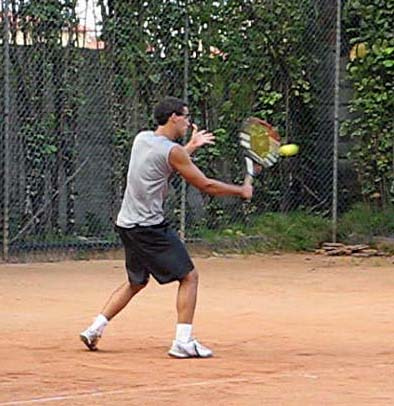<image>Color stripping on boys shoe? It's not clear what the color stripping on the boy's shoe is. It could be blue, black, or black and white. What brand are the man's shoes? It is unanswerable to determine the brand of the man's shoes. It could be Nike, Puma or Adidas. Color stripping on boys shoe? I don't know if there is color stripping on the boy's shoe. It can be seen both blue and black. What brand are the man's shoes? It is difficult to determine the brand of the man's shoes. Multiple answers are provided, including 'not possible', 'i don't know', and "can't tell". 